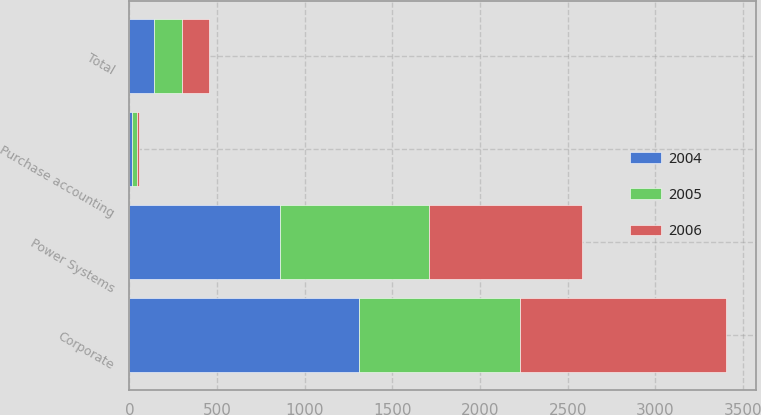<chart> <loc_0><loc_0><loc_500><loc_500><stacked_bar_chart><ecel><fcel>Power Systems<fcel>Corporate<fcel>Total<fcel>Purchase accounting<nl><fcel>2004<fcel>860.2<fcel>1307.1<fcel>140.3<fcel>13.3<nl><fcel>2006<fcel>867.8<fcel>1173.1<fcel>156.5<fcel>14.7<nl><fcel>2005<fcel>850.2<fcel>921<fcel>159.4<fcel>27.3<nl></chart> 